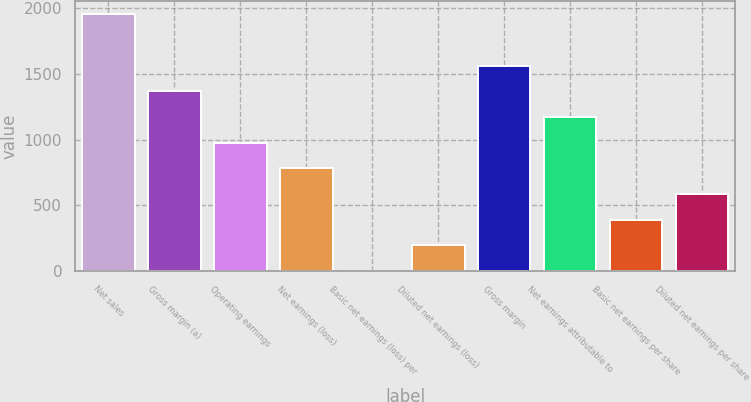Convert chart to OTSL. <chart><loc_0><loc_0><loc_500><loc_500><bar_chart><fcel>Net sales<fcel>Gross margin (a)<fcel>Operating earnings<fcel>Net earnings (loss)<fcel>Basic net earnings (loss) per<fcel>Diluted net earnings (loss)<fcel>Gross margin<fcel>Net earnings attributable to<fcel>Basic net earnings per share<fcel>Diluted net earnings per share<nl><fcel>1952.2<fcel>1366.58<fcel>976.16<fcel>780.95<fcel>0.11<fcel>195.32<fcel>1561.79<fcel>1171.37<fcel>390.53<fcel>585.74<nl></chart> 